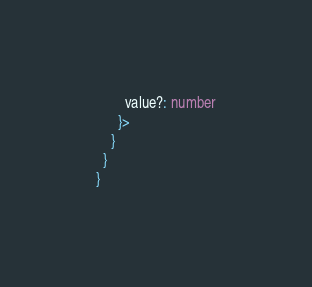Convert code to text. <code><loc_0><loc_0><loc_500><loc_500><_TypeScript_>        value?: number
      }>
    }
  }
}
</code> 